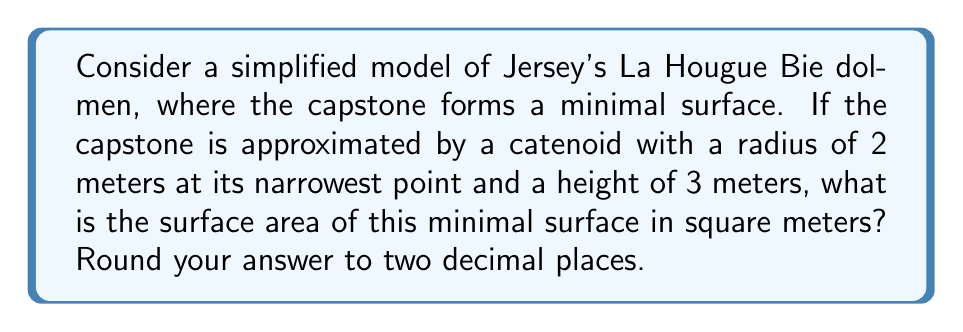Teach me how to tackle this problem. Let's approach this step-by-step:

1) The surface of a catenoid is a minimal surface described by the parametric equations:

   $$x = a \cosh(\frac{z}{a}) \cos(\theta)$$
   $$y = a \cosh(\frac{z}{a}) \sin(\theta)$$
   $$z = z$$

   where $a$ is the radius at the narrowest point.

2) The surface area of a catenoid is given by the formula:

   $$A = 2\pi a^2 \left[\cosh(\frac{h}{a}) - 1\right]$$

   where $h$ is half the height of the catenoid.

3) In our case:
   $a = 2$ meters (radius at narrowest point)
   $h = 1.5$ meters (half of the total height)

4) Substituting these values into the formula:

   $$A = 2\pi (2^2) \left[\cosh(\frac{1.5}{2}) - 1\right]$$

5) Simplify:
   $$A = 8\pi \left[\cosh(0.75) - 1\right]$$

6) Calculate:
   $$A \approx 8\pi [1.2946 - 1]$$
   $$A \approx 8\pi (0.2946)$$
   $$A \approx 7.4033$$

7) Rounding to two decimal places:
   $$A \approx 7.40 \text{ m}^2$$
Answer: 7.40 m² 